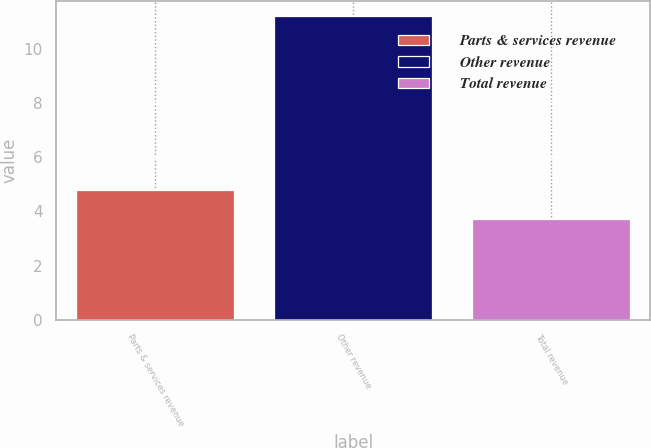Convert chart. <chart><loc_0><loc_0><loc_500><loc_500><bar_chart><fcel>Parts & services revenue<fcel>Other revenue<fcel>Total revenue<nl><fcel>4.8<fcel>11.2<fcel>3.7<nl></chart> 